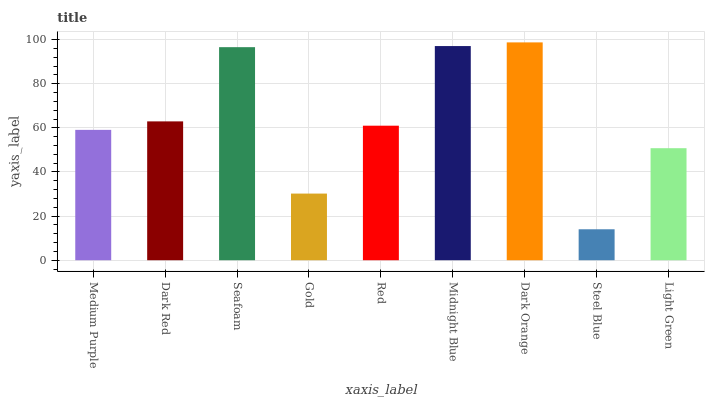Is Steel Blue the minimum?
Answer yes or no. Yes. Is Dark Orange the maximum?
Answer yes or no. Yes. Is Dark Red the minimum?
Answer yes or no. No. Is Dark Red the maximum?
Answer yes or no. No. Is Dark Red greater than Medium Purple?
Answer yes or no. Yes. Is Medium Purple less than Dark Red?
Answer yes or no. Yes. Is Medium Purple greater than Dark Red?
Answer yes or no. No. Is Dark Red less than Medium Purple?
Answer yes or no. No. Is Red the high median?
Answer yes or no. Yes. Is Red the low median?
Answer yes or no. Yes. Is Medium Purple the high median?
Answer yes or no. No. Is Gold the low median?
Answer yes or no. No. 